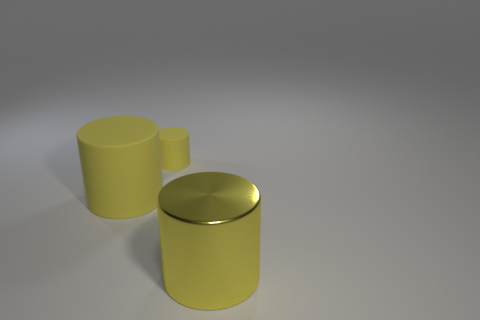How many yellow cylinders must be subtracted to get 1 yellow cylinders? 2 Subtract all shiny cylinders. How many cylinders are left? 2 Subtract 1 cylinders. How many cylinders are left? 2 Add 1 big matte cylinders. How many big matte cylinders are left? 2 Add 3 large green shiny objects. How many large green shiny objects exist? 3 Add 2 large things. How many objects exist? 5 Subtract 0 purple cubes. How many objects are left? 3 Subtract all blue cylinders. Subtract all brown spheres. How many cylinders are left? 3 Subtract all small cylinders. Subtract all big purple matte cylinders. How many objects are left? 2 